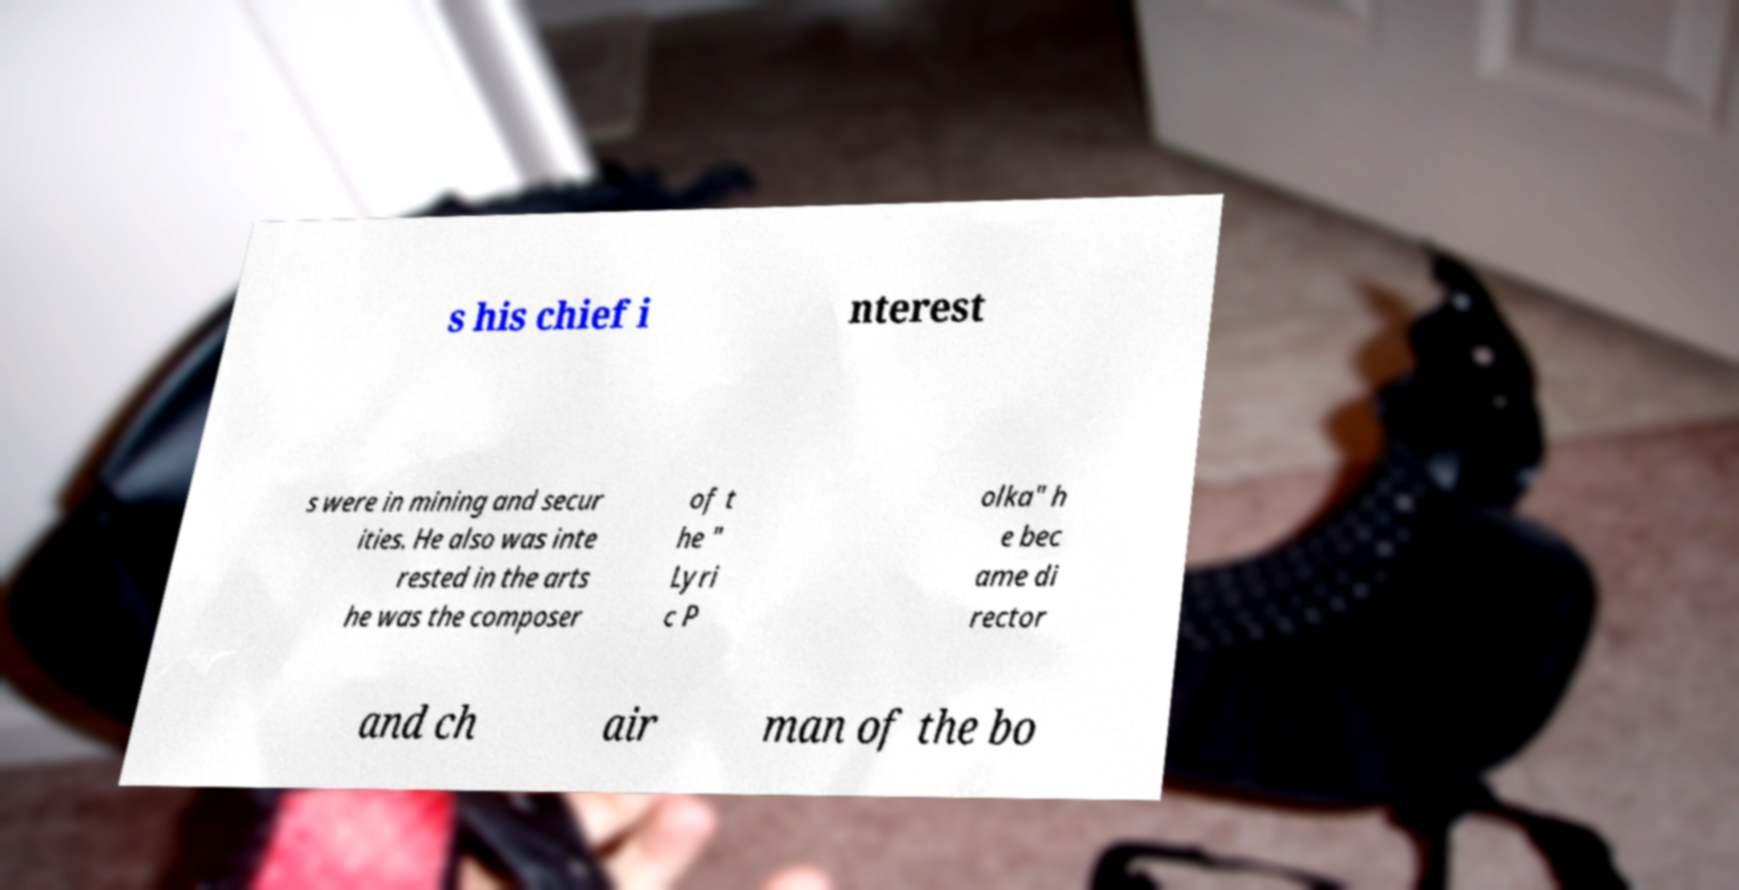Please read and relay the text visible in this image. What does it say? s his chief i nterest s were in mining and secur ities. He also was inte rested in the arts he was the composer of t he " Lyri c P olka" h e bec ame di rector and ch air man of the bo 